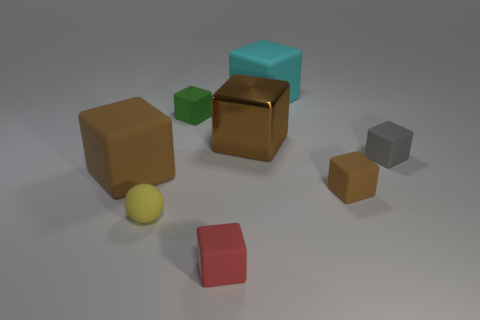What could be the purpose of these objects, and why might one have a shiny surface while the others do not? While these objects may not have an inherent purpose as they stand, they resemble a collection of educational or developmental toys designed to teach the recognition of shapes, colors, and materials. The shiny surfaced cube stands out and can serve as a means to introduce concepts of light reflection and different material properties to a learner. Could this different surface texture indicate usage or signify something special? The unique surface texture of the shiny cube could signify a special role, like being a 'treasure' amid the other more commonplace blocks with a matte finish. In a learning or play context, it might be used to draw attention or reward discovery, encouraging exploration and interaction. 